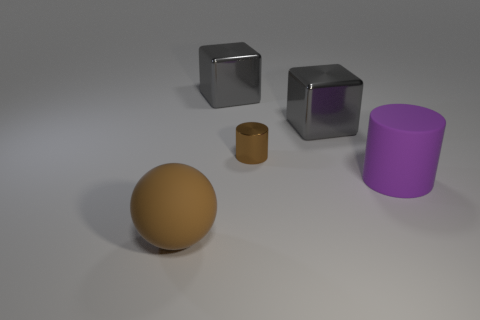Does the ball have the same color as the small object?
Give a very brief answer. Yes. What is the shape of the brown thing that is behind the brown object that is in front of the cylinder that is in front of the brown cylinder?
Offer a terse response. Cylinder. How many things are either big rubber objects left of the purple matte object or big brown things on the left side of the tiny brown thing?
Your answer should be very brief. 1. There is a metallic thing that is to the right of the brown thing that is to the right of the ball; what size is it?
Your answer should be compact. Large. There is a big rubber object that is in front of the large purple matte cylinder; does it have the same color as the small metallic cylinder?
Provide a succinct answer. Yes. Are there any other purple matte things that have the same shape as the small object?
Provide a succinct answer. Yes. What is the color of the matte thing that is the same size as the brown rubber sphere?
Make the answer very short. Purple. How big is the cylinder that is to the left of the big purple cylinder?
Offer a terse response. Small. Is there a shiny cube on the right side of the large shiny object to the left of the tiny shiny cylinder?
Provide a short and direct response. Yes. Do the object in front of the purple object and the small brown cylinder have the same material?
Your answer should be very brief. No. 